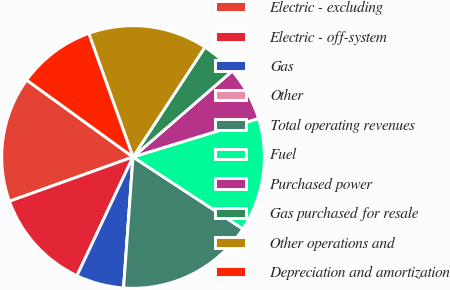Convert chart. <chart><loc_0><loc_0><loc_500><loc_500><pie_chart><fcel>Electric - excluding<fcel>Electric - off-system<fcel>Gas<fcel>Other<fcel>Total operating revenues<fcel>Fuel<fcel>Purchased power<fcel>Gas purchased for resale<fcel>Other operations and<fcel>Depreciation and amortization<nl><fcel>15.44%<fcel>12.5%<fcel>5.88%<fcel>0.0%<fcel>16.91%<fcel>13.97%<fcel>6.62%<fcel>4.41%<fcel>14.7%<fcel>9.56%<nl></chart> 